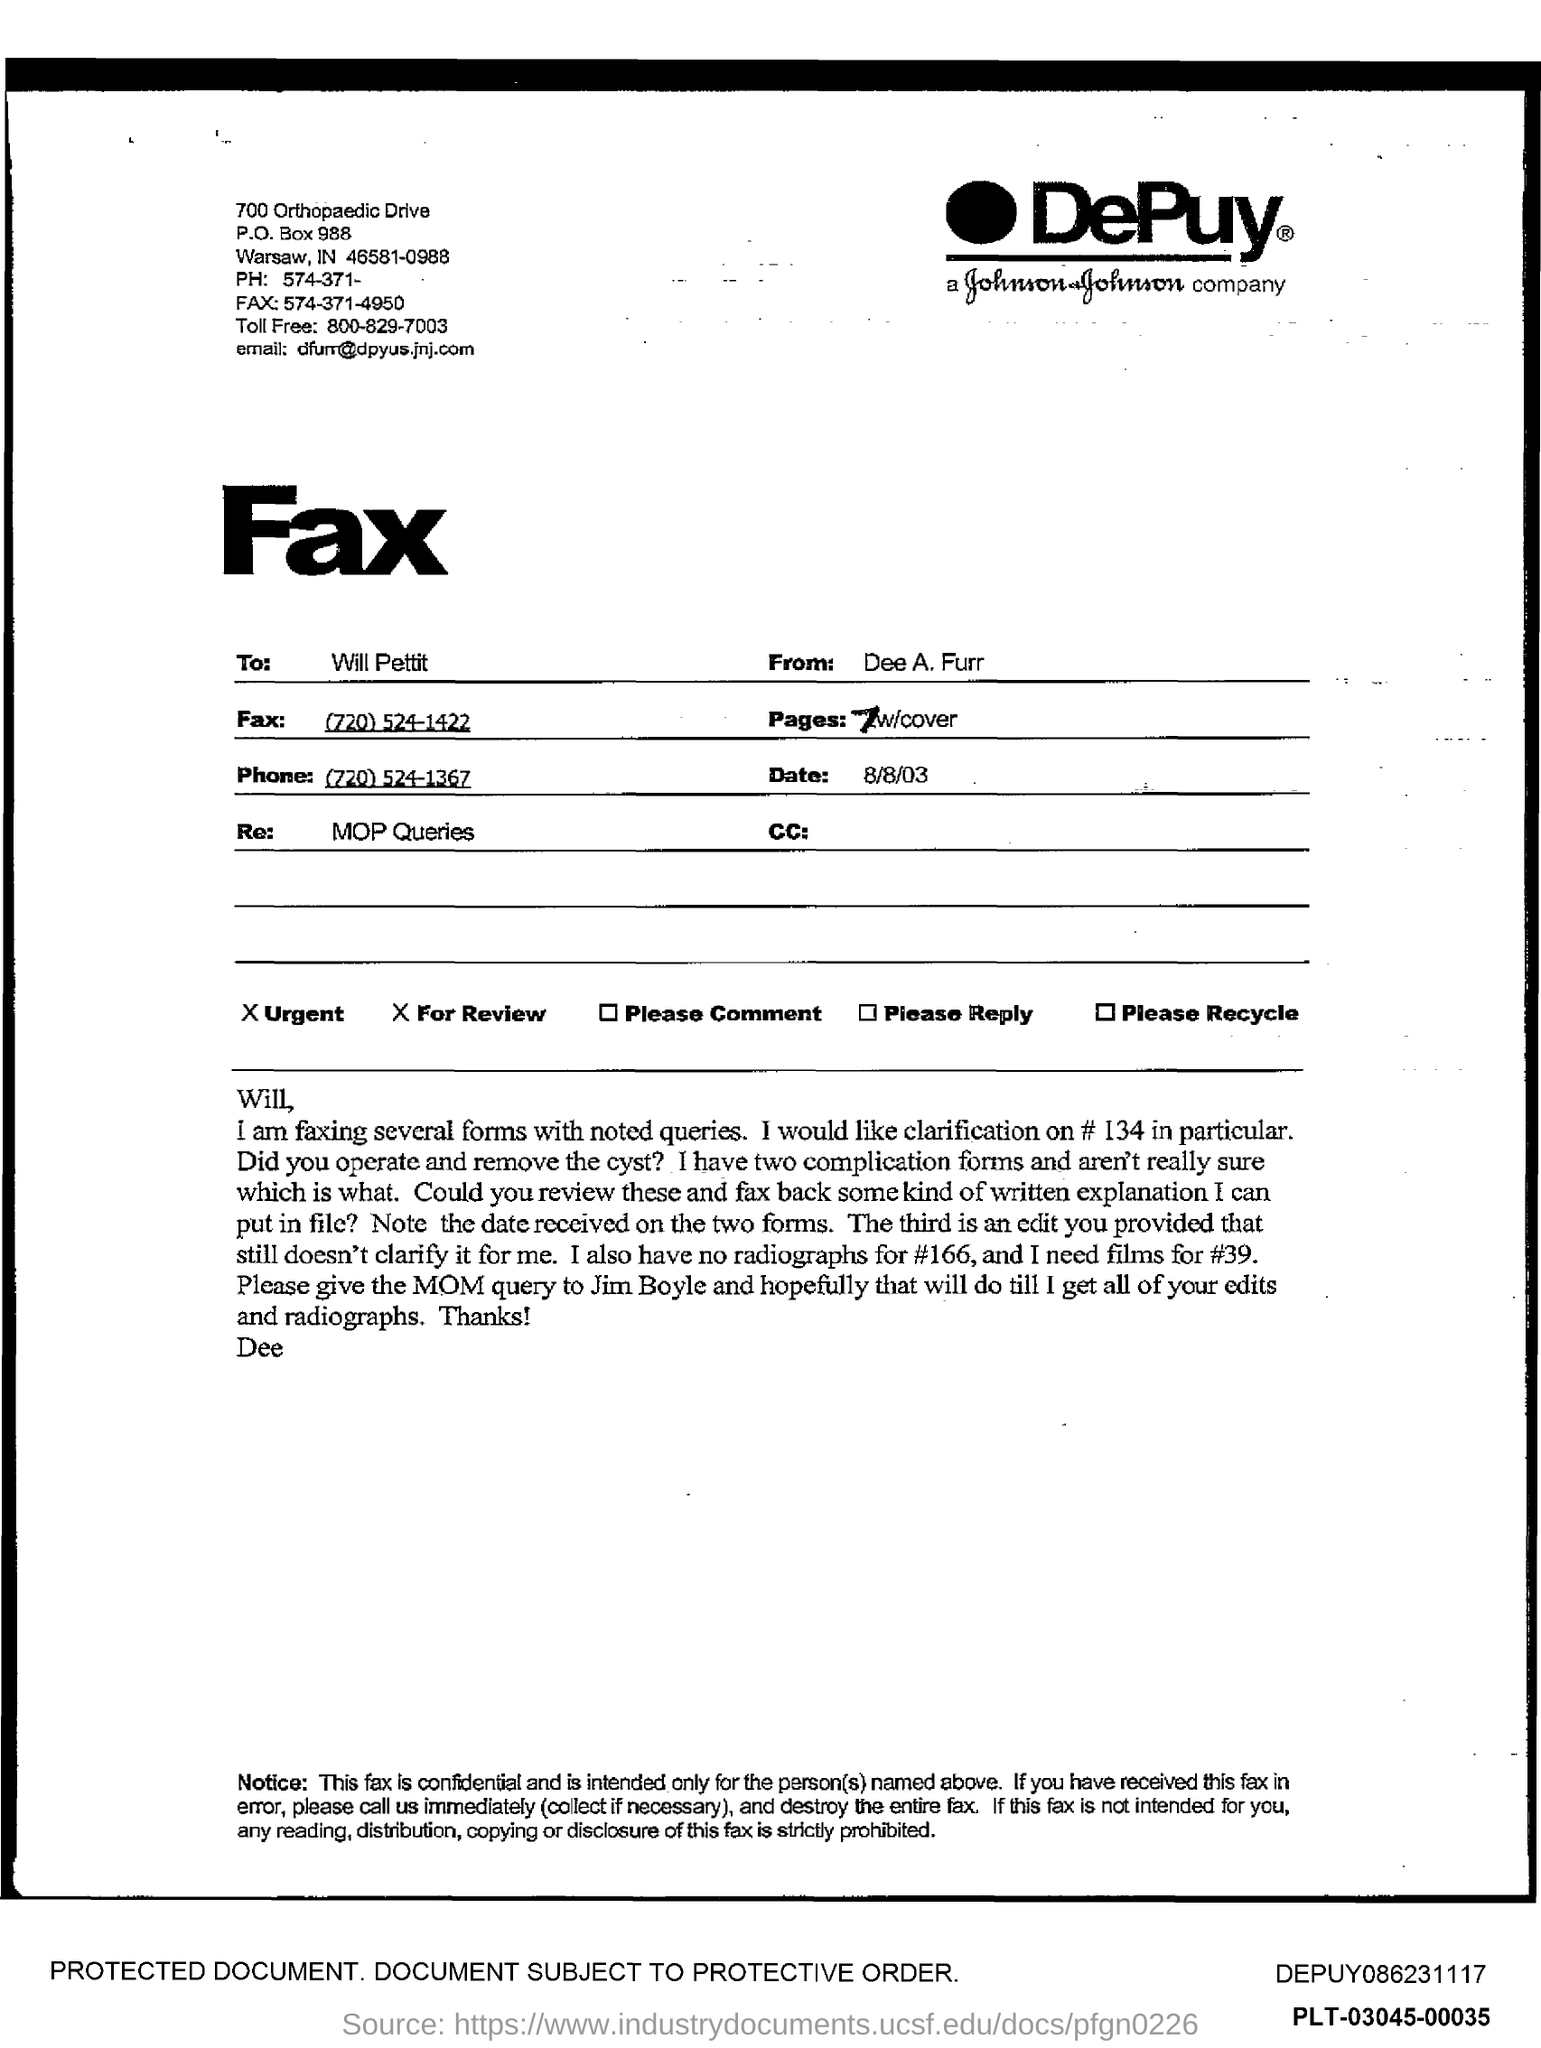Who is this Fax from? The fax is sent by Dee A. Furr, who appears to be affiliated with DePuy, a Johnson & Johnson company, as indicated by the logo and contact details on the fax header. The correspondence is likely professional in nature, concerning medical operational queries. 